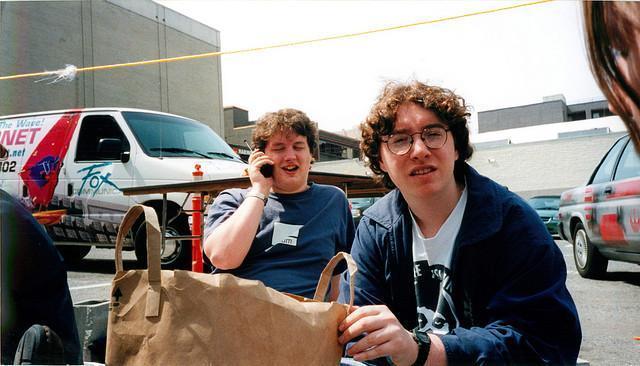How many people are there?
Give a very brief answer. 4. How many cars are in the picture?
Give a very brief answer. 2. How many bottles of wine are on the table?
Give a very brief answer. 0. 